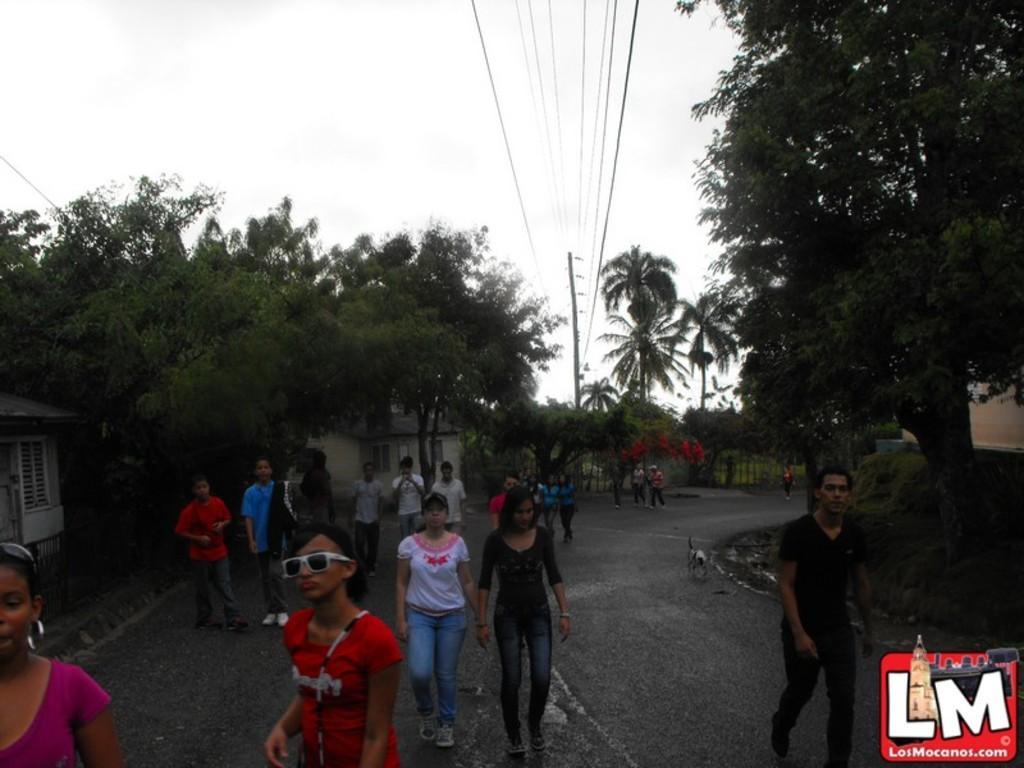Could you give a brief overview of what you see in this image? In this image on a road there are many people walking. On the top on a pole there are wires. 